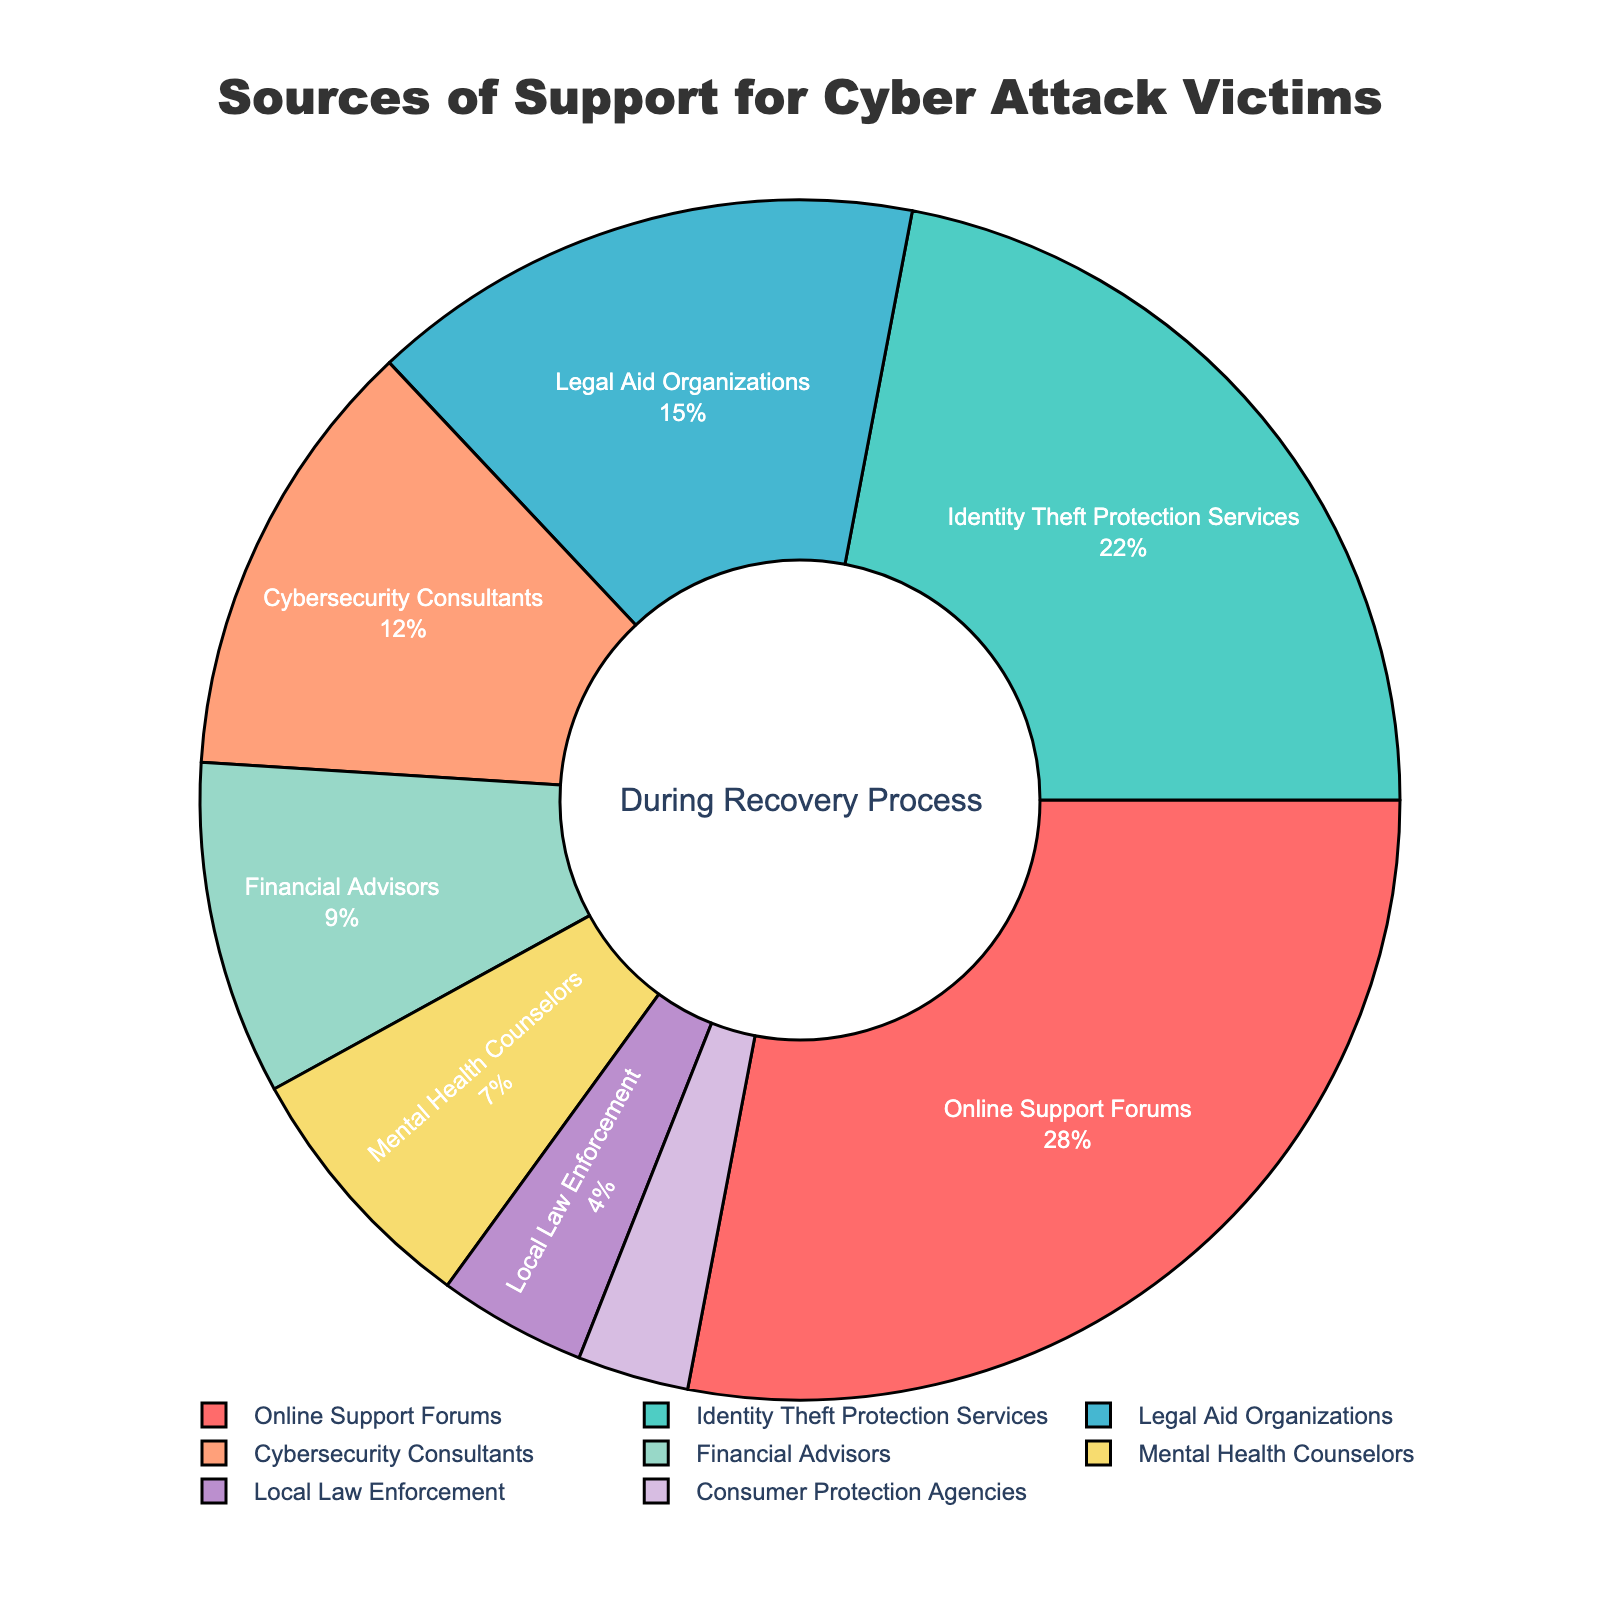What is the largest source of support utilized by cyber attack victims during the recovery process? By observing the chart, we see that the largest segment is "Online Support Forums" with 28%.
Answer: Online Support Forums Which two categories combined account for half of the sources of support? "Online Support Forums" (28%) and "Identity Theft Protection Services" (22%) together make 28% + 22% = 50%.
Answer: Online Support Forums and Identity Theft Protection Services Among Legal Aid Organizations, Cybersecurity Consultants, and Financial Advisors, which category has the smallest percentage? Comparing Legal Aid Organizations (15%), Cybersecurity Consultants (12%), and Financial Advisors (9%), we see Financial Advisors have the smallest percentage.
Answer: Financial Advisors How does the percentage of Mental Health Counselors compare to that of Local Law Enforcement? Mental Health Counselors have 7%, while Local Law Enforcement has 4%. So, Mental Health Counselors have a higher percentage.
Answer: Mental Health Counselors are higher What is the total percentage for the three smallest categories in the chart? The three smallest categories are Local Law Enforcement (4%), Consumer Protection Agencies (3%), and Mental Health Counselors (7%). Summing them gives 4% + 3% + 7% = 14%.
Answer: 14% Is the percentage of Cybersecurity Consultants greater than, less than, or equal to the combined percentage of Legal Aid Organizations and Financial Advisors? Cybersecurity Consultants have 12%. Legal Aid Organizations and Financial Advisors together have 15% + 9% = 24%. Thus, Cybersecurity Consultants is less than their combined percentage.
Answer: Less than What proportion of the chart is represented by identity-theft-related services? Identity Theft Protection Services account for 22%.
Answer: 22% If Local Law Enforcement and Consumer Protection Agencies doubled their percentages, how would their combined total compare to the current percentage for Legal Aid Organizations? Local Law Enforcement would have 8% (2*4%) and Consumer Protection Agencies 6% (2*3%), totaling 8% + 6% = 14%. Legal Aid Organizations have 15%, so it would be slightly less than that.
Answer: Slightly less 